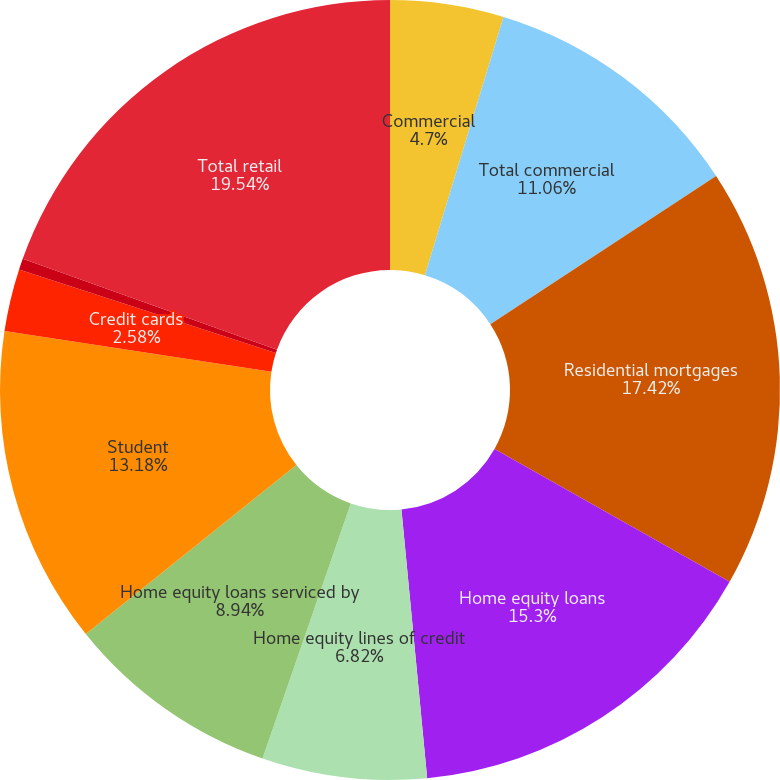Convert chart. <chart><loc_0><loc_0><loc_500><loc_500><pie_chart><fcel>Commercial<fcel>Total commercial<fcel>Residential mortgages<fcel>Home equity loans<fcel>Home equity lines of credit<fcel>Home equity loans serviced by<fcel>Student<fcel>Credit cards<fcel>Other retail<fcel>Total retail<nl><fcel>4.7%<fcel>11.06%<fcel>17.42%<fcel>15.3%<fcel>6.82%<fcel>8.94%<fcel>13.18%<fcel>2.58%<fcel>0.46%<fcel>19.54%<nl></chart> 